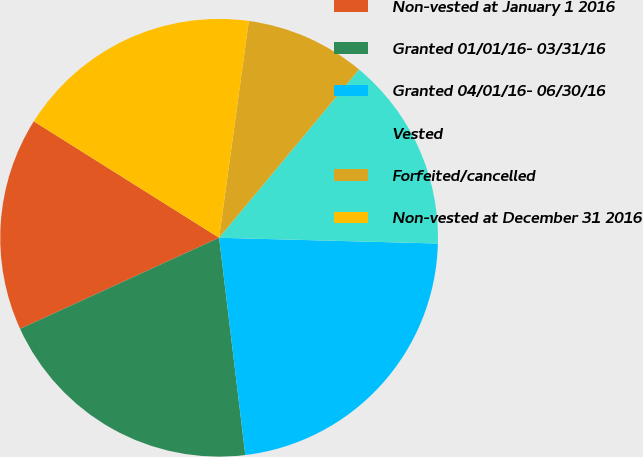Convert chart. <chart><loc_0><loc_0><loc_500><loc_500><pie_chart><fcel>Non-vested at January 1 2016<fcel>Granted 01/01/16- 03/31/16<fcel>Granted 04/01/16- 06/30/16<fcel>Vested<fcel>Forfeited/cancelled<fcel>Non-vested at December 31 2016<nl><fcel>15.76%<fcel>20.08%<fcel>22.67%<fcel>14.38%<fcel>8.87%<fcel>18.24%<nl></chart> 